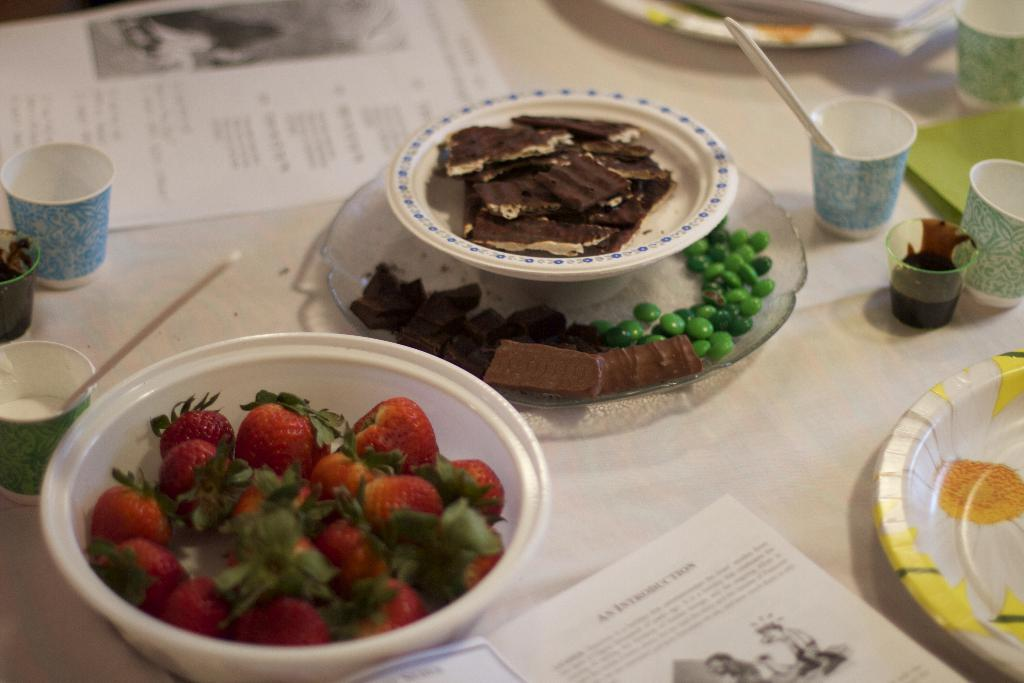What piece of furniture is present in the image? There is a table in the image. What is placed on the table? There is a paper, plates, bowls, glasses, strawberries, and a book on the table. What type of food is visible on the table? Strawberries are visible on the table. Can you see a chess game being played on the table in the image? There is no chess game visible in the image. Is there a scarecrow standing next to the table in the image? There is no scarecrow present in the image. 